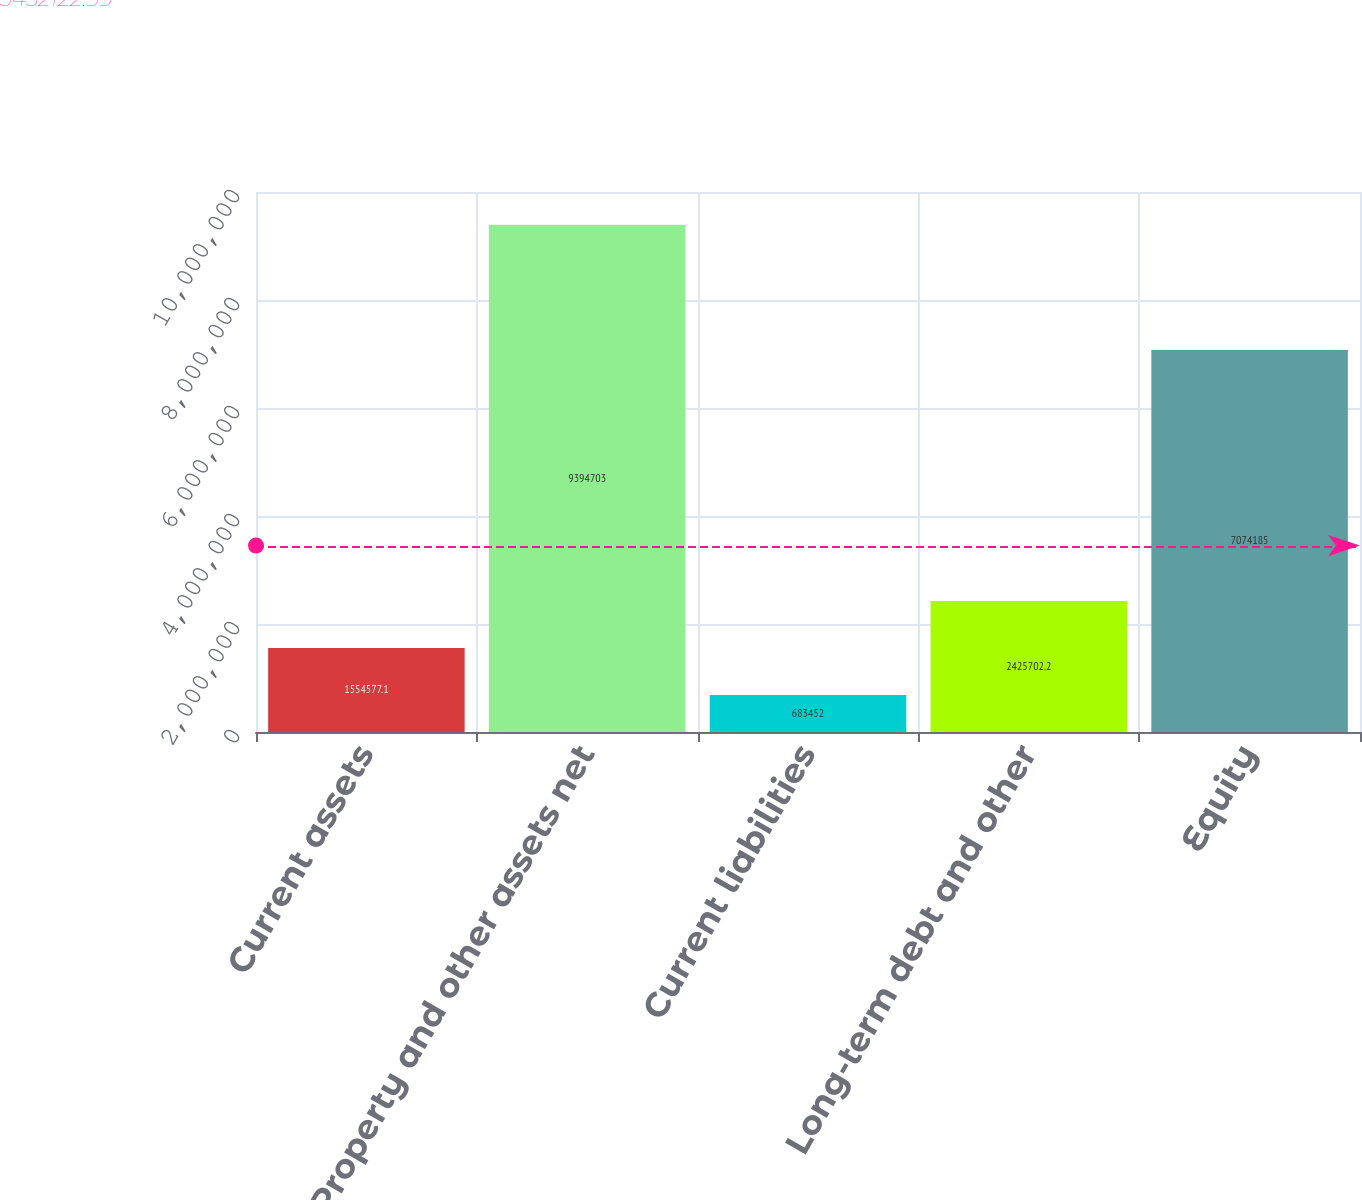Convert chart. <chart><loc_0><loc_0><loc_500><loc_500><bar_chart><fcel>Current assets<fcel>Property and other assets net<fcel>Current liabilities<fcel>Long-term debt and other<fcel>Equity<nl><fcel>1.55458e+06<fcel>9.3947e+06<fcel>683452<fcel>2.4257e+06<fcel>7.07418e+06<nl></chart> 